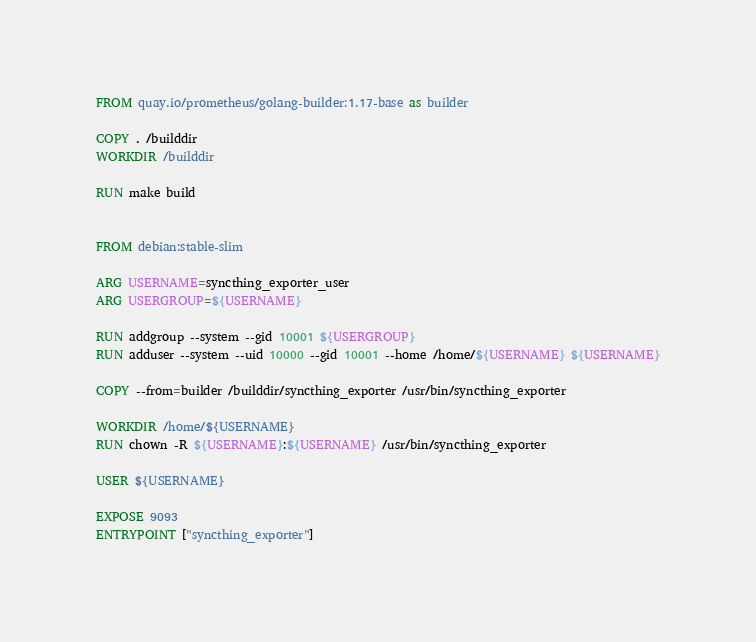Convert code to text. <code><loc_0><loc_0><loc_500><loc_500><_Dockerfile_>FROM quay.io/prometheus/golang-builder:1.17-base as builder

COPY . /builddir
WORKDIR /builddir

RUN make build


FROM debian:stable-slim

ARG USERNAME=syncthing_exporter_user
ARG USERGROUP=${USERNAME}

RUN addgroup --system --gid 10001 ${USERGROUP}
RUN adduser --system --uid 10000 --gid 10001 --home /home/${USERNAME} ${USERNAME}

COPY --from=builder /builddir/syncthing_exporter /usr/bin/syncthing_exporter

WORKDIR /home/${USERNAME}
RUN chown -R ${USERNAME}:${USERNAME} /usr/bin/syncthing_exporter

USER ${USERNAME}

EXPOSE 9093
ENTRYPOINT ["syncthing_exporter"] 

</code> 